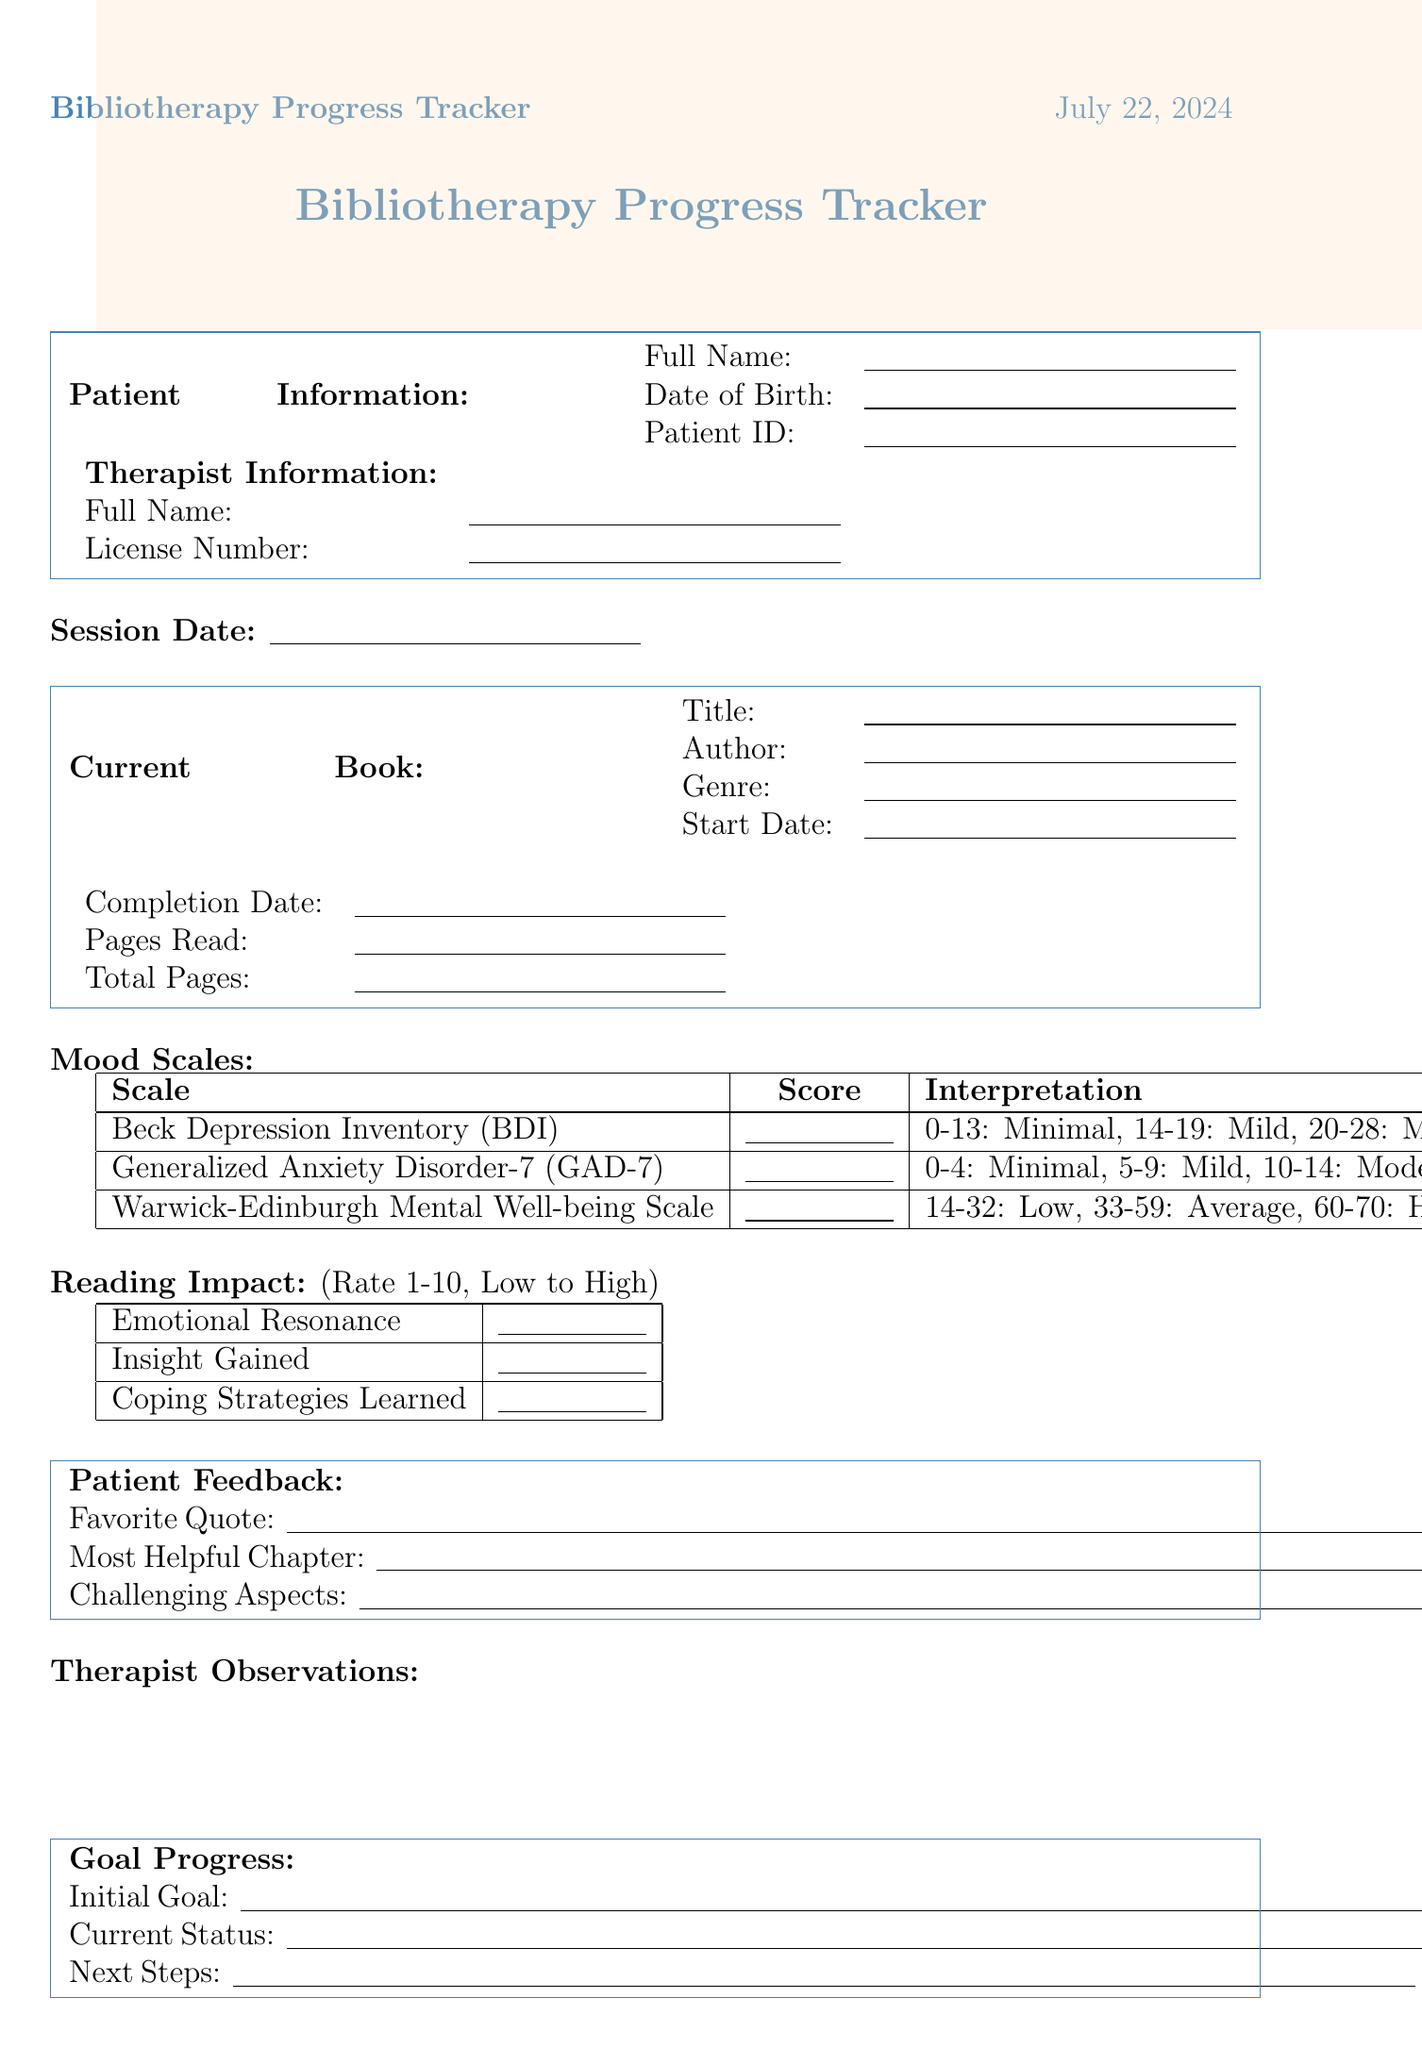what is the author's name of the recommended book "Feeling Good: The New Mood Therapy"? The author is specified in the "Book Recommendations" section next to the title.
Answer: David D. Burns what is the genre of "Man's Search for Meaning"? The genre is mentioned in the "Book Recommendations" section.
Answer: Memoir / Psychology what does the interpretation for a score of 20 in the Beck Depression Inventory (BDI) indicate? The interpretation for a score is given alongside the score in the "Mood Scales" section.
Answer: Moderate depression 